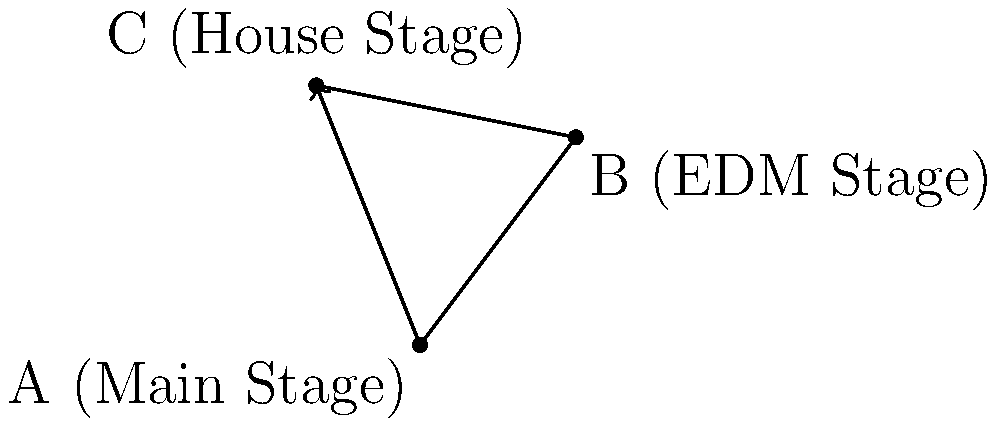At an electronic music festival, you move from the Main Stage (A) to the EDM Stage (B), and then to the House Stage (C). What is the magnitude of the displacement vector from your starting point to your final position? Let's approach this step-by-step:

1) First, we need to find the displacement vector from A to C. This is our final displacement, regardless of the path taken.

2) The coordinates are:
   A (0, 0)
   B (3, 4) - not needed for final calculation
   C (-2, 5)

3) The displacement vector AC is:
   $\vec{AC} = C - A = (-2-0, 5-0) = (-2, 5)$

4) To find the magnitude of this vector, we use the Pythagorean theorem:
   $|\vec{AC}| = \sqrt{(-2)^2 + 5^2}$

5) Simplifying:
   $|\vec{AC}| = \sqrt{4 + 25} = \sqrt{29}$

6) $\sqrt{29} \approx 5.39$ units

Therefore, the magnitude of the displacement vector is $\sqrt{29}$ units, or approximately 5.39 units.
Answer: $\sqrt{29}$ units 